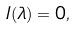<formula> <loc_0><loc_0><loc_500><loc_500>I ( \lambda ) = 0 ,</formula> 